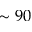Convert formula to latex. <formula><loc_0><loc_0><loc_500><loc_500>\sim 9 0</formula> 